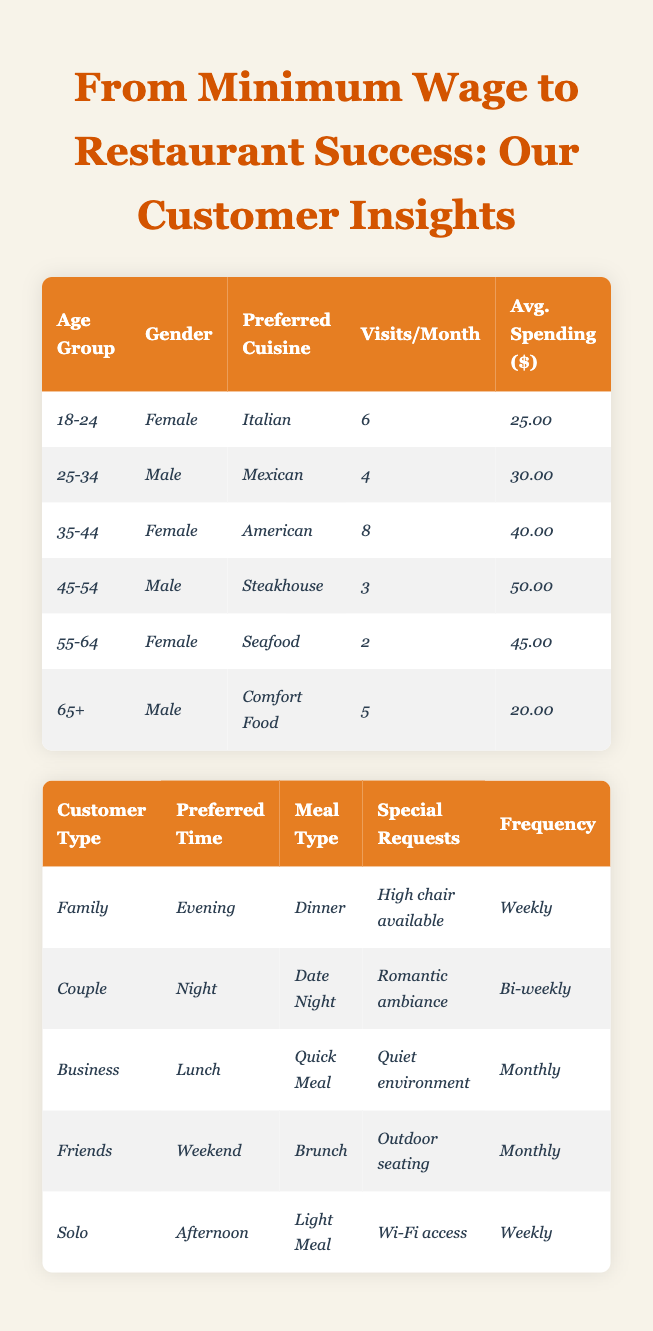What is the preferred cuisine for customers aged 18-24? Referring to the table, the entry for the age group 18-24 shows that the preferred cuisine is Italian.
Answer: Italian How many visits per month do customers aged 35-44 make? The table indicates that customers in the age group 35-44 have an average of 8 visits per month.
Answer: 8 Which customer type visits the restaurant most frequently? By analyzing the frequency of visits, the Family and Solo customer types visit weekly, making them the most frequent visitors.
Answer: Family and Solo What is the average spending for customers aged 45-54? The table states that customers aged 45-54 have an average spending of $50.00.
Answer: $50.00 Is the preferred time for Business customers lunchtime? The table shows that Business customers prefer lunchtime for their visits, confirming the fact.
Answer: Yes How many total visits do customers aged 25-34 and 35-44 make on average per month? For age group 25-34, there are 4 visits per month, and for 35-44, there are 8 visits. The total is 4 + 8 = 12 visits per month.
Answer: 12 Do more female customers prefer Italian cuisine than male customers? In the table, the only female customer who specified preferred cuisine is in the 18-24 age group with Italian. The male customers mentioned different cuisines, so it's not possible to definitively say yes or no.
Answer: No What is the average spending of customers who dine in the evening? The Family customer type prefers dining in the evening at $50 when considering their special requests and frequency. Since they dine weekly, the average remains $50.00.
Answer: $50.00 Which preferred cuisine has the highest average spending? By checking the average spending for each preferred cuisine, Steakhouse averages $50.00, which is the highest value among the options.
Answer: Steakhouse How many total customers prefer a romantic ambiance for their evening visits? Looking at the dining preferences table, only the Couple customer type makes this request in their special requests. Thus, the total is 1.
Answer: 1 